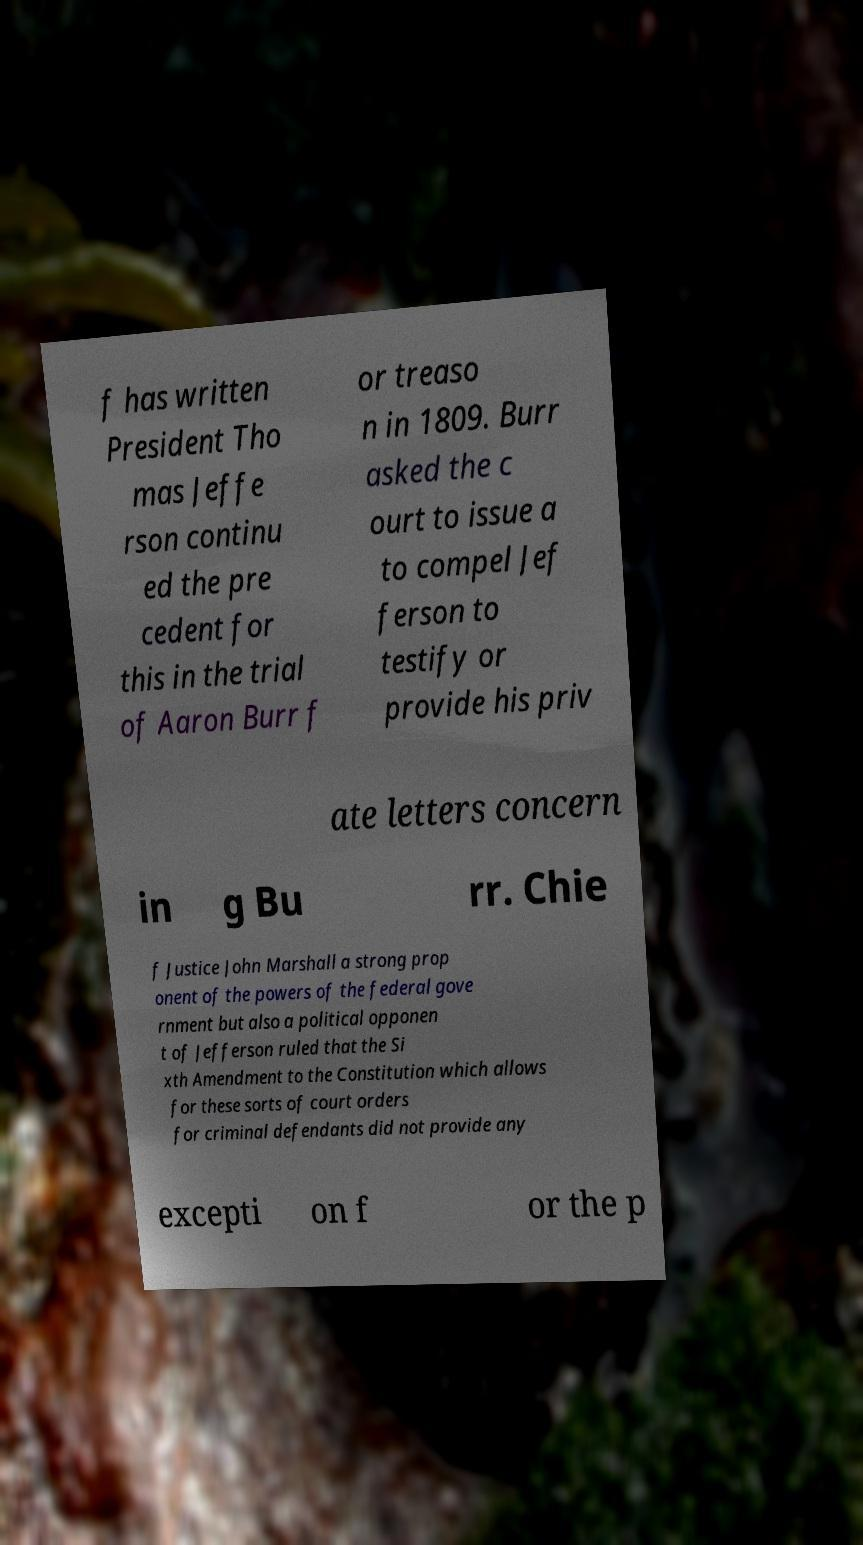Could you extract and type out the text from this image? f has written President Tho mas Jeffe rson continu ed the pre cedent for this in the trial of Aaron Burr f or treaso n in 1809. Burr asked the c ourt to issue a to compel Jef ferson to testify or provide his priv ate letters concern in g Bu rr. Chie f Justice John Marshall a strong prop onent of the powers of the federal gove rnment but also a political opponen t of Jefferson ruled that the Si xth Amendment to the Constitution which allows for these sorts of court orders for criminal defendants did not provide any excepti on f or the p 